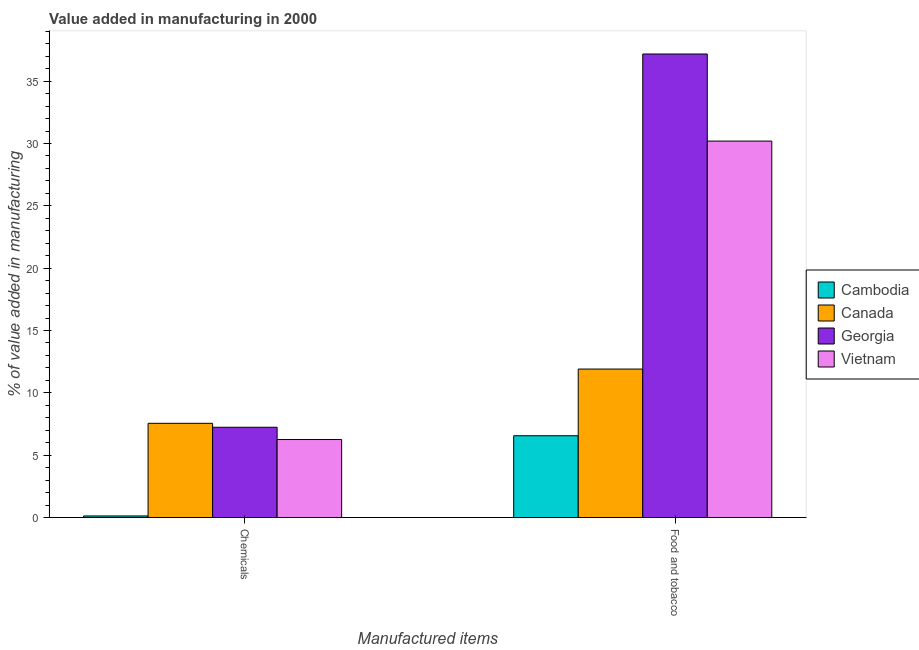How many different coloured bars are there?
Make the answer very short. 4. How many bars are there on the 2nd tick from the left?
Provide a succinct answer. 4. How many bars are there on the 2nd tick from the right?
Offer a very short reply. 4. What is the label of the 2nd group of bars from the left?
Make the answer very short. Food and tobacco. What is the value added by manufacturing food and tobacco in Vietnam?
Your answer should be very brief. 30.19. Across all countries, what is the maximum value added by manufacturing food and tobacco?
Your answer should be very brief. 37.18. Across all countries, what is the minimum value added by  manufacturing chemicals?
Offer a terse response. 0.13. In which country was the value added by manufacturing food and tobacco maximum?
Your answer should be compact. Georgia. In which country was the value added by manufacturing food and tobacco minimum?
Your response must be concise. Cambodia. What is the total value added by manufacturing food and tobacco in the graph?
Make the answer very short. 85.84. What is the difference between the value added by manufacturing food and tobacco in Georgia and that in Vietnam?
Provide a short and direct response. 6.98. What is the difference between the value added by  manufacturing chemicals in Georgia and the value added by manufacturing food and tobacco in Cambodia?
Keep it short and to the point. 0.68. What is the average value added by manufacturing food and tobacco per country?
Your answer should be very brief. 21.46. What is the difference between the value added by  manufacturing chemicals and value added by manufacturing food and tobacco in Cambodia?
Keep it short and to the point. -6.43. What is the ratio of the value added by  manufacturing chemicals in Canada to that in Vietnam?
Provide a short and direct response. 1.21. In how many countries, is the value added by  manufacturing chemicals greater than the average value added by  manufacturing chemicals taken over all countries?
Keep it short and to the point. 3. What does the 4th bar from the left in Chemicals represents?
Your answer should be very brief. Vietnam. What does the 2nd bar from the right in Food and tobacco represents?
Your answer should be very brief. Georgia. Are all the bars in the graph horizontal?
Make the answer very short. No. Are the values on the major ticks of Y-axis written in scientific E-notation?
Your answer should be very brief. No. How many legend labels are there?
Provide a short and direct response. 4. How are the legend labels stacked?
Provide a short and direct response. Vertical. What is the title of the graph?
Provide a short and direct response. Value added in manufacturing in 2000. Does "Gambia, The" appear as one of the legend labels in the graph?
Offer a terse response. No. What is the label or title of the X-axis?
Offer a terse response. Manufactured items. What is the label or title of the Y-axis?
Provide a short and direct response. % of value added in manufacturing. What is the % of value added in manufacturing in Cambodia in Chemicals?
Provide a short and direct response. 0.13. What is the % of value added in manufacturing of Canada in Chemicals?
Offer a terse response. 7.56. What is the % of value added in manufacturing of Georgia in Chemicals?
Your response must be concise. 7.24. What is the % of value added in manufacturing of Vietnam in Chemicals?
Offer a terse response. 6.26. What is the % of value added in manufacturing in Cambodia in Food and tobacco?
Make the answer very short. 6.56. What is the % of value added in manufacturing in Canada in Food and tobacco?
Ensure brevity in your answer.  11.91. What is the % of value added in manufacturing in Georgia in Food and tobacco?
Offer a terse response. 37.18. What is the % of value added in manufacturing of Vietnam in Food and tobacco?
Give a very brief answer. 30.19. Across all Manufactured items, what is the maximum % of value added in manufacturing of Cambodia?
Provide a short and direct response. 6.56. Across all Manufactured items, what is the maximum % of value added in manufacturing of Canada?
Provide a short and direct response. 11.91. Across all Manufactured items, what is the maximum % of value added in manufacturing in Georgia?
Your answer should be very brief. 37.18. Across all Manufactured items, what is the maximum % of value added in manufacturing of Vietnam?
Give a very brief answer. 30.19. Across all Manufactured items, what is the minimum % of value added in manufacturing of Cambodia?
Provide a short and direct response. 0.13. Across all Manufactured items, what is the minimum % of value added in manufacturing of Canada?
Keep it short and to the point. 7.56. Across all Manufactured items, what is the minimum % of value added in manufacturing of Georgia?
Offer a very short reply. 7.24. Across all Manufactured items, what is the minimum % of value added in manufacturing in Vietnam?
Keep it short and to the point. 6.26. What is the total % of value added in manufacturing in Cambodia in the graph?
Provide a succinct answer. 6.69. What is the total % of value added in manufacturing of Canada in the graph?
Your answer should be compact. 19.47. What is the total % of value added in manufacturing of Georgia in the graph?
Ensure brevity in your answer.  44.42. What is the total % of value added in manufacturing of Vietnam in the graph?
Give a very brief answer. 36.45. What is the difference between the % of value added in manufacturing in Cambodia in Chemicals and that in Food and tobacco?
Ensure brevity in your answer.  -6.43. What is the difference between the % of value added in manufacturing in Canada in Chemicals and that in Food and tobacco?
Provide a succinct answer. -4.35. What is the difference between the % of value added in manufacturing of Georgia in Chemicals and that in Food and tobacco?
Offer a very short reply. -29.94. What is the difference between the % of value added in manufacturing of Vietnam in Chemicals and that in Food and tobacco?
Provide a succinct answer. -23.93. What is the difference between the % of value added in manufacturing in Cambodia in Chemicals and the % of value added in manufacturing in Canada in Food and tobacco?
Offer a very short reply. -11.78. What is the difference between the % of value added in manufacturing of Cambodia in Chemicals and the % of value added in manufacturing of Georgia in Food and tobacco?
Ensure brevity in your answer.  -37.05. What is the difference between the % of value added in manufacturing of Cambodia in Chemicals and the % of value added in manufacturing of Vietnam in Food and tobacco?
Ensure brevity in your answer.  -30.06. What is the difference between the % of value added in manufacturing of Canada in Chemicals and the % of value added in manufacturing of Georgia in Food and tobacco?
Ensure brevity in your answer.  -29.62. What is the difference between the % of value added in manufacturing in Canada in Chemicals and the % of value added in manufacturing in Vietnam in Food and tobacco?
Provide a short and direct response. -22.63. What is the difference between the % of value added in manufacturing of Georgia in Chemicals and the % of value added in manufacturing of Vietnam in Food and tobacco?
Your response must be concise. -22.95. What is the average % of value added in manufacturing of Cambodia per Manufactured items?
Your response must be concise. 3.34. What is the average % of value added in manufacturing of Canada per Manufactured items?
Your response must be concise. 9.74. What is the average % of value added in manufacturing in Georgia per Manufactured items?
Provide a short and direct response. 22.21. What is the average % of value added in manufacturing in Vietnam per Manufactured items?
Give a very brief answer. 18.23. What is the difference between the % of value added in manufacturing in Cambodia and % of value added in manufacturing in Canada in Chemicals?
Make the answer very short. -7.43. What is the difference between the % of value added in manufacturing of Cambodia and % of value added in manufacturing of Georgia in Chemicals?
Provide a short and direct response. -7.11. What is the difference between the % of value added in manufacturing of Cambodia and % of value added in manufacturing of Vietnam in Chemicals?
Make the answer very short. -6.13. What is the difference between the % of value added in manufacturing of Canada and % of value added in manufacturing of Georgia in Chemicals?
Offer a very short reply. 0.32. What is the difference between the % of value added in manufacturing of Canada and % of value added in manufacturing of Vietnam in Chemicals?
Your answer should be very brief. 1.3. What is the difference between the % of value added in manufacturing in Georgia and % of value added in manufacturing in Vietnam in Chemicals?
Keep it short and to the point. 0.98. What is the difference between the % of value added in manufacturing of Cambodia and % of value added in manufacturing of Canada in Food and tobacco?
Provide a succinct answer. -5.35. What is the difference between the % of value added in manufacturing of Cambodia and % of value added in manufacturing of Georgia in Food and tobacco?
Your answer should be compact. -30.62. What is the difference between the % of value added in manufacturing in Cambodia and % of value added in manufacturing in Vietnam in Food and tobacco?
Your answer should be very brief. -23.63. What is the difference between the % of value added in manufacturing of Canada and % of value added in manufacturing of Georgia in Food and tobacco?
Give a very brief answer. -25.27. What is the difference between the % of value added in manufacturing of Canada and % of value added in manufacturing of Vietnam in Food and tobacco?
Make the answer very short. -18.28. What is the difference between the % of value added in manufacturing in Georgia and % of value added in manufacturing in Vietnam in Food and tobacco?
Offer a terse response. 6.98. What is the ratio of the % of value added in manufacturing in Cambodia in Chemicals to that in Food and tobacco?
Offer a very short reply. 0.02. What is the ratio of the % of value added in manufacturing of Canada in Chemicals to that in Food and tobacco?
Provide a succinct answer. 0.63. What is the ratio of the % of value added in manufacturing of Georgia in Chemicals to that in Food and tobacco?
Make the answer very short. 0.19. What is the ratio of the % of value added in manufacturing in Vietnam in Chemicals to that in Food and tobacco?
Your response must be concise. 0.21. What is the difference between the highest and the second highest % of value added in manufacturing of Cambodia?
Your response must be concise. 6.43. What is the difference between the highest and the second highest % of value added in manufacturing of Canada?
Give a very brief answer. 4.35. What is the difference between the highest and the second highest % of value added in manufacturing of Georgia?
Make the answer very short. 29.94. What is the difference between the highest and the second highest % of value added in manufacturing of Vietnam?
Your answer should be compact. 23.93. What is the difference between the highest and the lowest % of value added in manufacturing of Cambodia?
Your answer should be very brief. 6.43. What is the difference between the highest and the lowest % of value added in manufacturing in Canada?
Make the answer very short. 4.35. What is the difference between the highest and the lowest % of value added in manufacturing of Georgia?
Ensure brevity in your answer.  29.94. What is the difference between the highest and the lowest % of value added in manufacturing in Vietnam?
Your response must be concise. 23.93. 